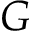Convert formula to latex. <formula><loc_0><loc_0><loc_500><loc_500>G</formula> 